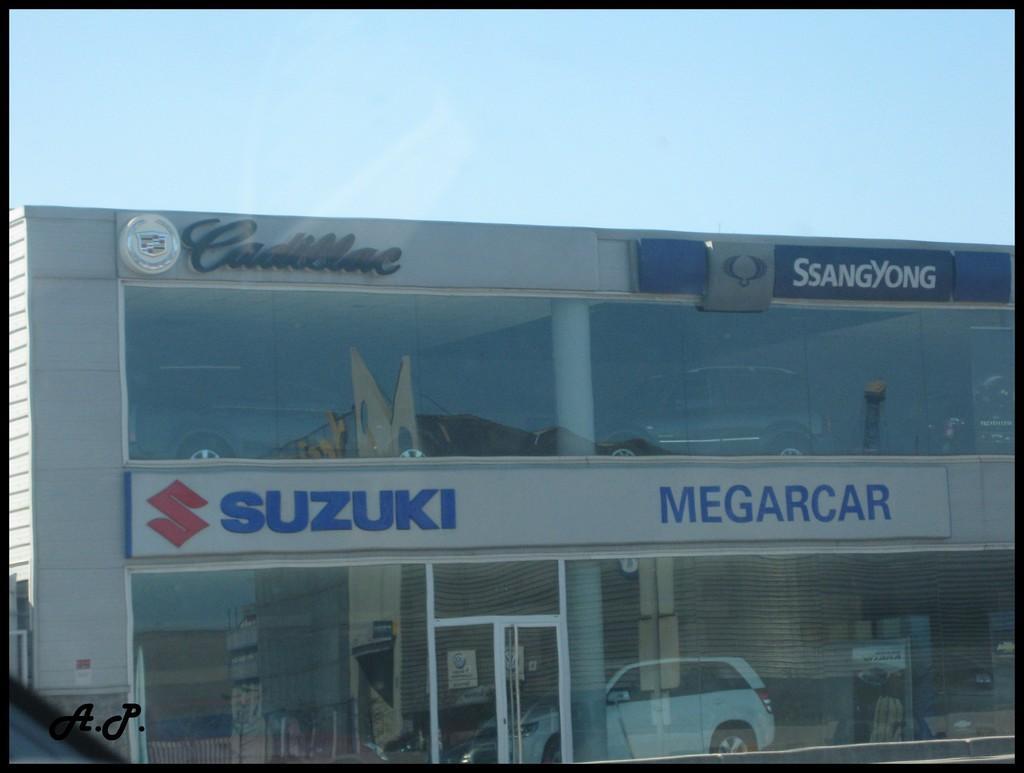Please provide a concise description of this image. In this image I can see the showroom of the cars. To the side of the cars I can the glasses. And there is a name Suzuki is written on the building. And these cars are in different color. In the back I can see the sky. 